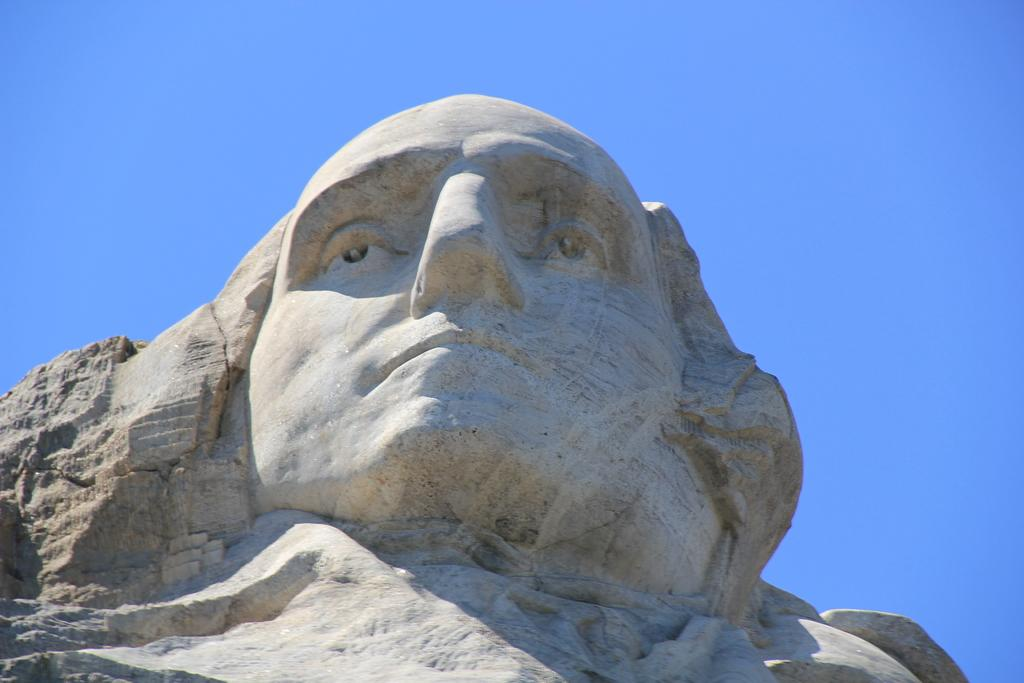What is the main subject of the image? There is a stone carved statue in the image. What can be seen in the background of the image? The sky is visible in the background of the image. What is the color of the sky in the image? The color of the sky is blue. Can you hear the bells ringing in the image? There are no bells present in the image, so it is not possible to hear them ringing. 